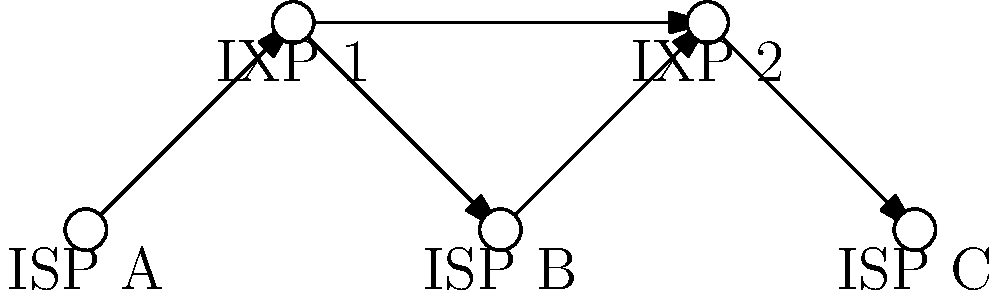In the context of net neutrality and internet backbone connections, analyze the network topology diagram above. If ISP A implements traffic shaping policies that slow down certain types of content, how might this affect the overall network performance and user experience for customers of ISP B and ISP C? Explain your reasoning using the concept of Internet Exchange Points (IXPs) shown in the diagram. To answer this question, let's break down the analysis step-by-step:

1. Network Structure:
   The diagram shows three Internet Service Providers (ISPs A, B, and C) connected through two Internet Exchange Points (IXPs 1 and 2).

2. Traffic Flow:
   Traffic from ISP A flows through IXP 1 to reach ISP B, and then through IXP 2 to reach ISP C.

3. Role of IXPs:
   IXPs serve as neutral meeting points where ISPs can exchange traffic directly, reducing costs and improving network efficiency.

4. Impact of ISP A's Traffic Shaping:
   a) Direct impact on ISP A's customers:
      - Certain types of content will be slowed down, affecting user experience.
   b) Impact on ISP B:
      - Traffic passing through IXP 1 from ISP A to ISP B may be already shaped.
      - ISP B's customers accessing content hosted on ISP A's network may experience slowdowns.
   c) Impact on ISP C:
      - Traffic from ISP A to ISP C must pass through both ISP B and two IXPs.
      - The shaped traffic from ISP A may cause congestion at IXP 1 and IXP 2.
      - ISP C's customers may experience degraded performance when accessing content that originates from or passes through ISP A's network.

5. Net Neutrality Implications:
   - ISP A's traffic shaping violates net neutrality principles by treating different types of content unequally.
   - This practice can lead to an unfair advantage for certain content providers and limit user choice.

6. Cascading Effects:
   - The performance issues may lead to increased load on IXP 1 and IXP 2 as they handle the shaped traffic.
   - ISP B and ISP C may need to implement their own traffic management strategies to mitigate the effects, potentially leading to further network inefficiencies.

7. User Experience:
   - Customers of all three ISPs may experience inconsistent performance depending on the type of content they're accessing and its origin.
   - This can lead to a fragmented internet experience, contradicting the principles of an open and equally accessible internet.

In conclusion, ISP A's traffic shaping policies can have far-reaching effects beyond its own network, potentially degrading performance and user experience across the entire interconnected system, highlighting the importance of net neutrality in maintaining a fair and efficient internet ecosystem.
Answer: ISP A's traffic shaping can degrade performance for ISP B and C customers, causing network-wide inefficiencies and inconsistent user experiences, undermining net neutrality principles. 